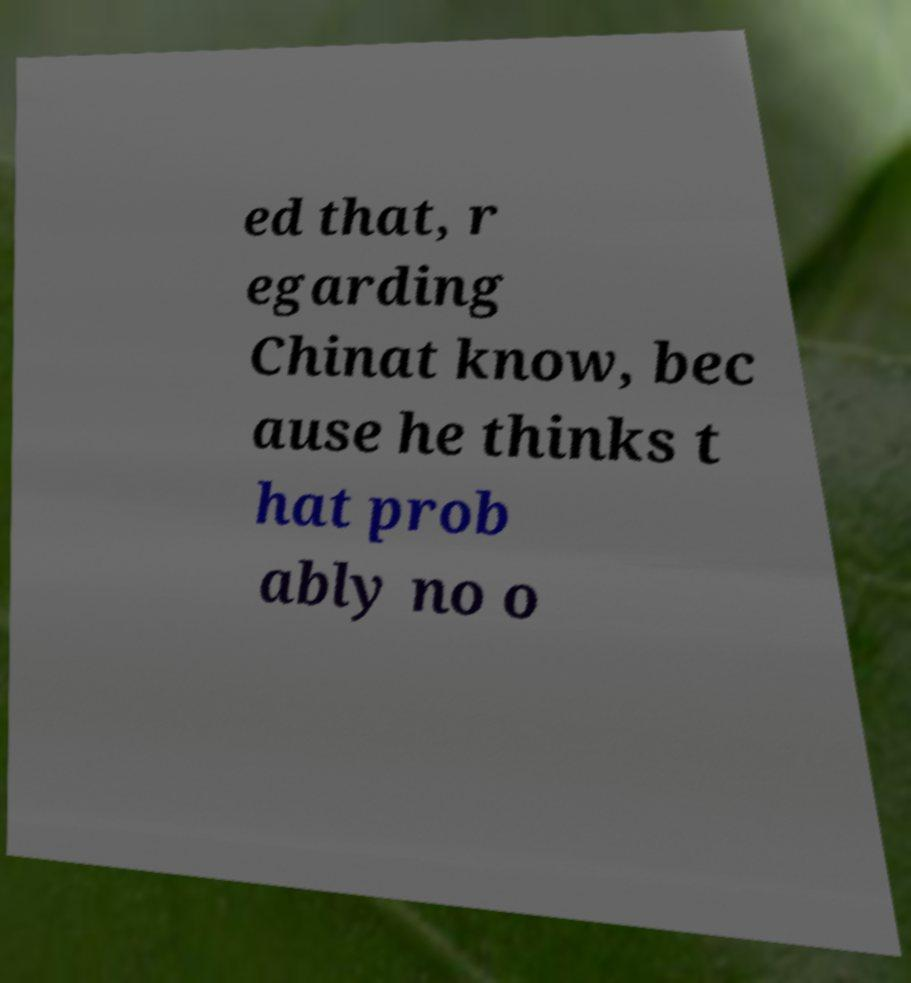Can you read and provide the text displayed in the image?This photo seems to have some interesting text. Can you extract and type it out for me? ed that, r egarding Chinat know, bec ause he thinks t hat prob ably no o 